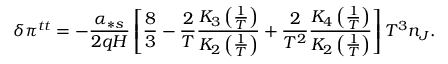Convert formula to latex. <formula><loc_0><loc_0><loc_500><loc_500>\delta \pi ^ { t t } = - \frac { \alpha _ { \ast s } } { 2 q H } \left [ \frac { 8 } { 3 } - \frac { 2 } { T } \frac { K _ { 3 } \left ( \frac { 1 } { T } \right ) } { K _ { 2 } \left ( \frac { 1 } { T } \right ) } + \frac { 2 } { T ^ { 2 } } \frac { K _ { 4 } \left ( \frac { 1 } { T } \right ) } { K _ { 2 } \left ( \frac { 1 } { T } \right ) } \right ] T ^ { 3 } n _ { J } .</formula> 